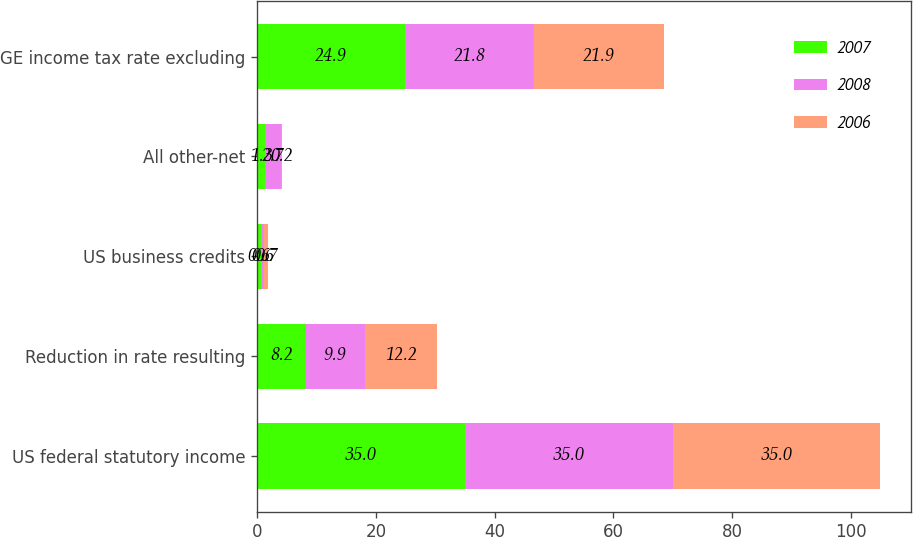Convert chart to OTSL. <chart><loc_0><loc_0><loc_500><loc_500><stacked_bar_chart><ecel><fcel>US federal statutory income<fcel>Reduction in rate resulting<fcel>US business credits<fcel>All other-net<fcel>GE income tax rate excluding<nl><fcel>2007<fcel>35<fcel>8.2<fcel>0.6<fcel>1.3<fcel>24.9<nl><fcel>2008<fcel>35<fcel>9.9<fcel>0.6<fcel>2.7<fcel>21.8<nl><fcel>2006<fcel>35<fcel>12.2<fcel>0.7<fcel>0.2<fcel>21.9<nl></chart> 